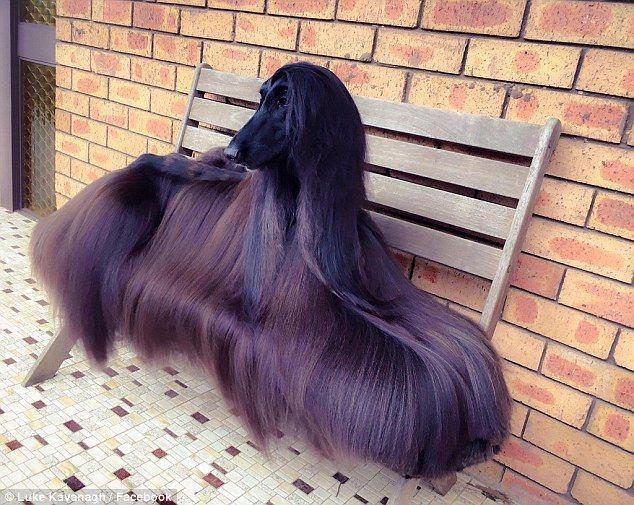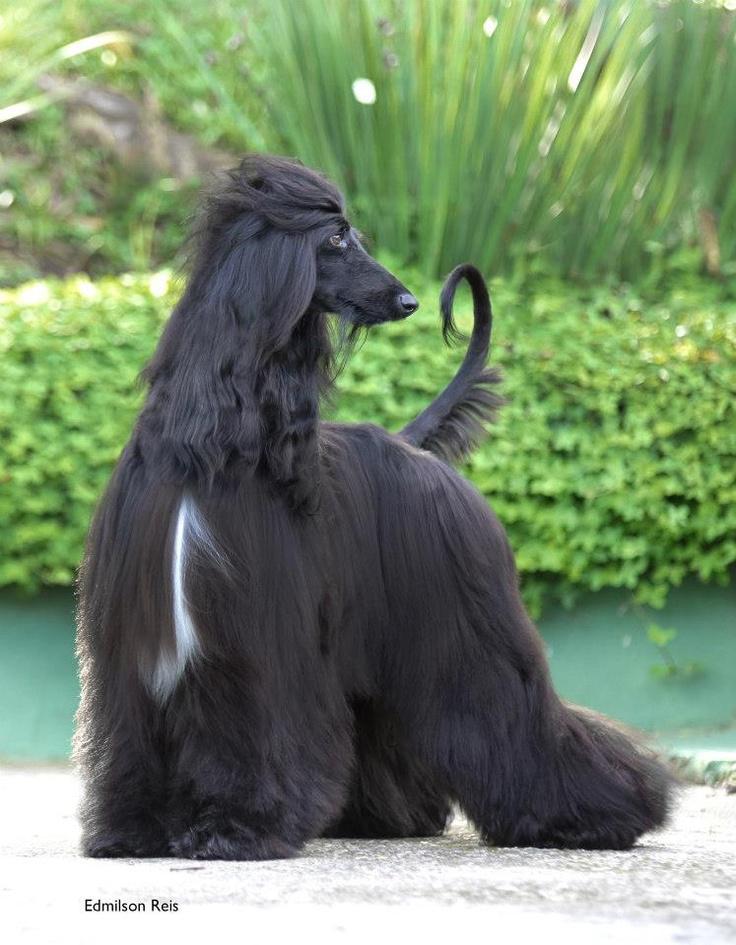The first image is the image on the left, the second image is the image on the right. Given the left and right images, does the statement "Exactly one dog is on the grass." hold true? Answer yes or no. No. The first image is the image on the left, the second image is the image on the right. For the images displayed, is the sentence "The left and right image contains the same number of dogs face left forward." factually correct? Answer yes or no. No. 